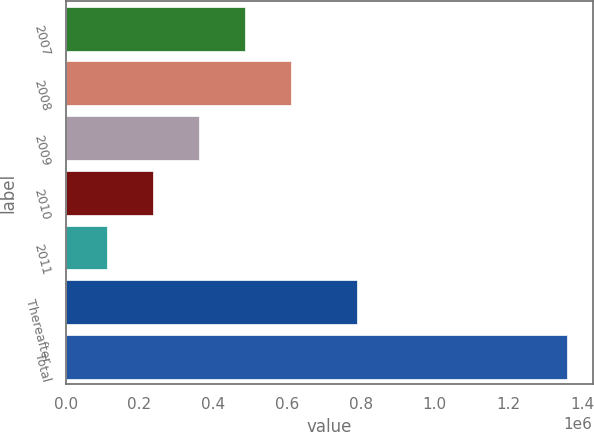Convert chart. <chart><loc_0><loc_0><loc_500><loc_500><bar_chart><fcel>2007<fcel>2008<fcel>2009<fcel>2010<fcel>2011<fcel>Thereafter<fcel>Total<nl><fcel>486708<fcel>611532<fcel>361885<fcel>237062<fcel>112238<fcel>789440<fcel>1.36047e+06<nl></chart> 